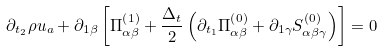Convert formula to latex. <formula><loc_0><loc_0><loc_500><loc_500>\partial _ { t _ { 2 } } \rho u _ { a } + \partial _ { 1 \beta } \left [ \Pi _ { \alpha \beta } ^ { \left ( 1 \right ) } + \frac { \Delta _ { t } } { 2 } \left ( \partial _ { t _ { 1 } } \Pi _ { \alpha \beta } ^ { \left ( 0 \right ) } + \partial _ { 1 \gamma } S _ { \alpha \beta \gamma } ^ { \left ( 0 \right ) } \right ) \right ] = 0</formula> 